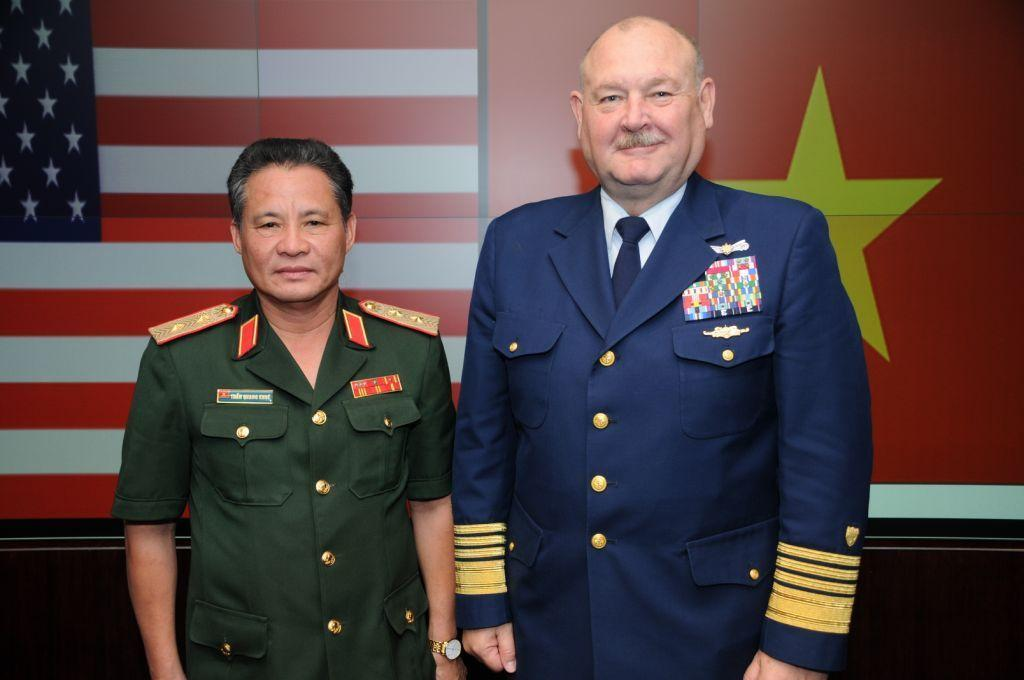How many people are present in the image? There are two men standing in the image. What can be seen in the background of the image? There are flags in the background of the image. What type of behavior is the flag exhibiting in the image? Flags do not exhibit behavior, as they are inanimate objects. 